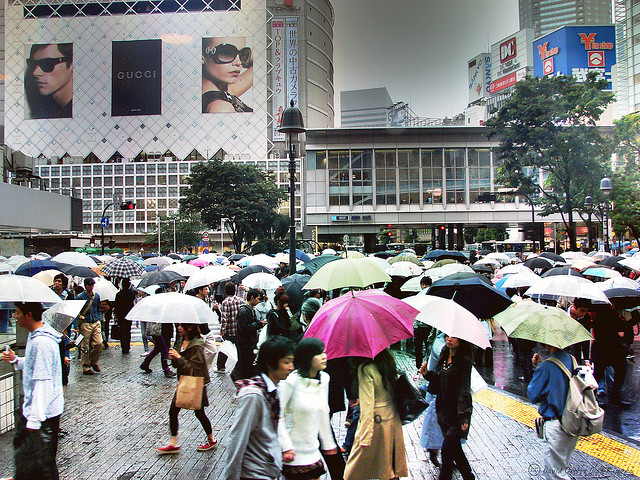Please extract the text content from this image. CUCCI TOP DC 